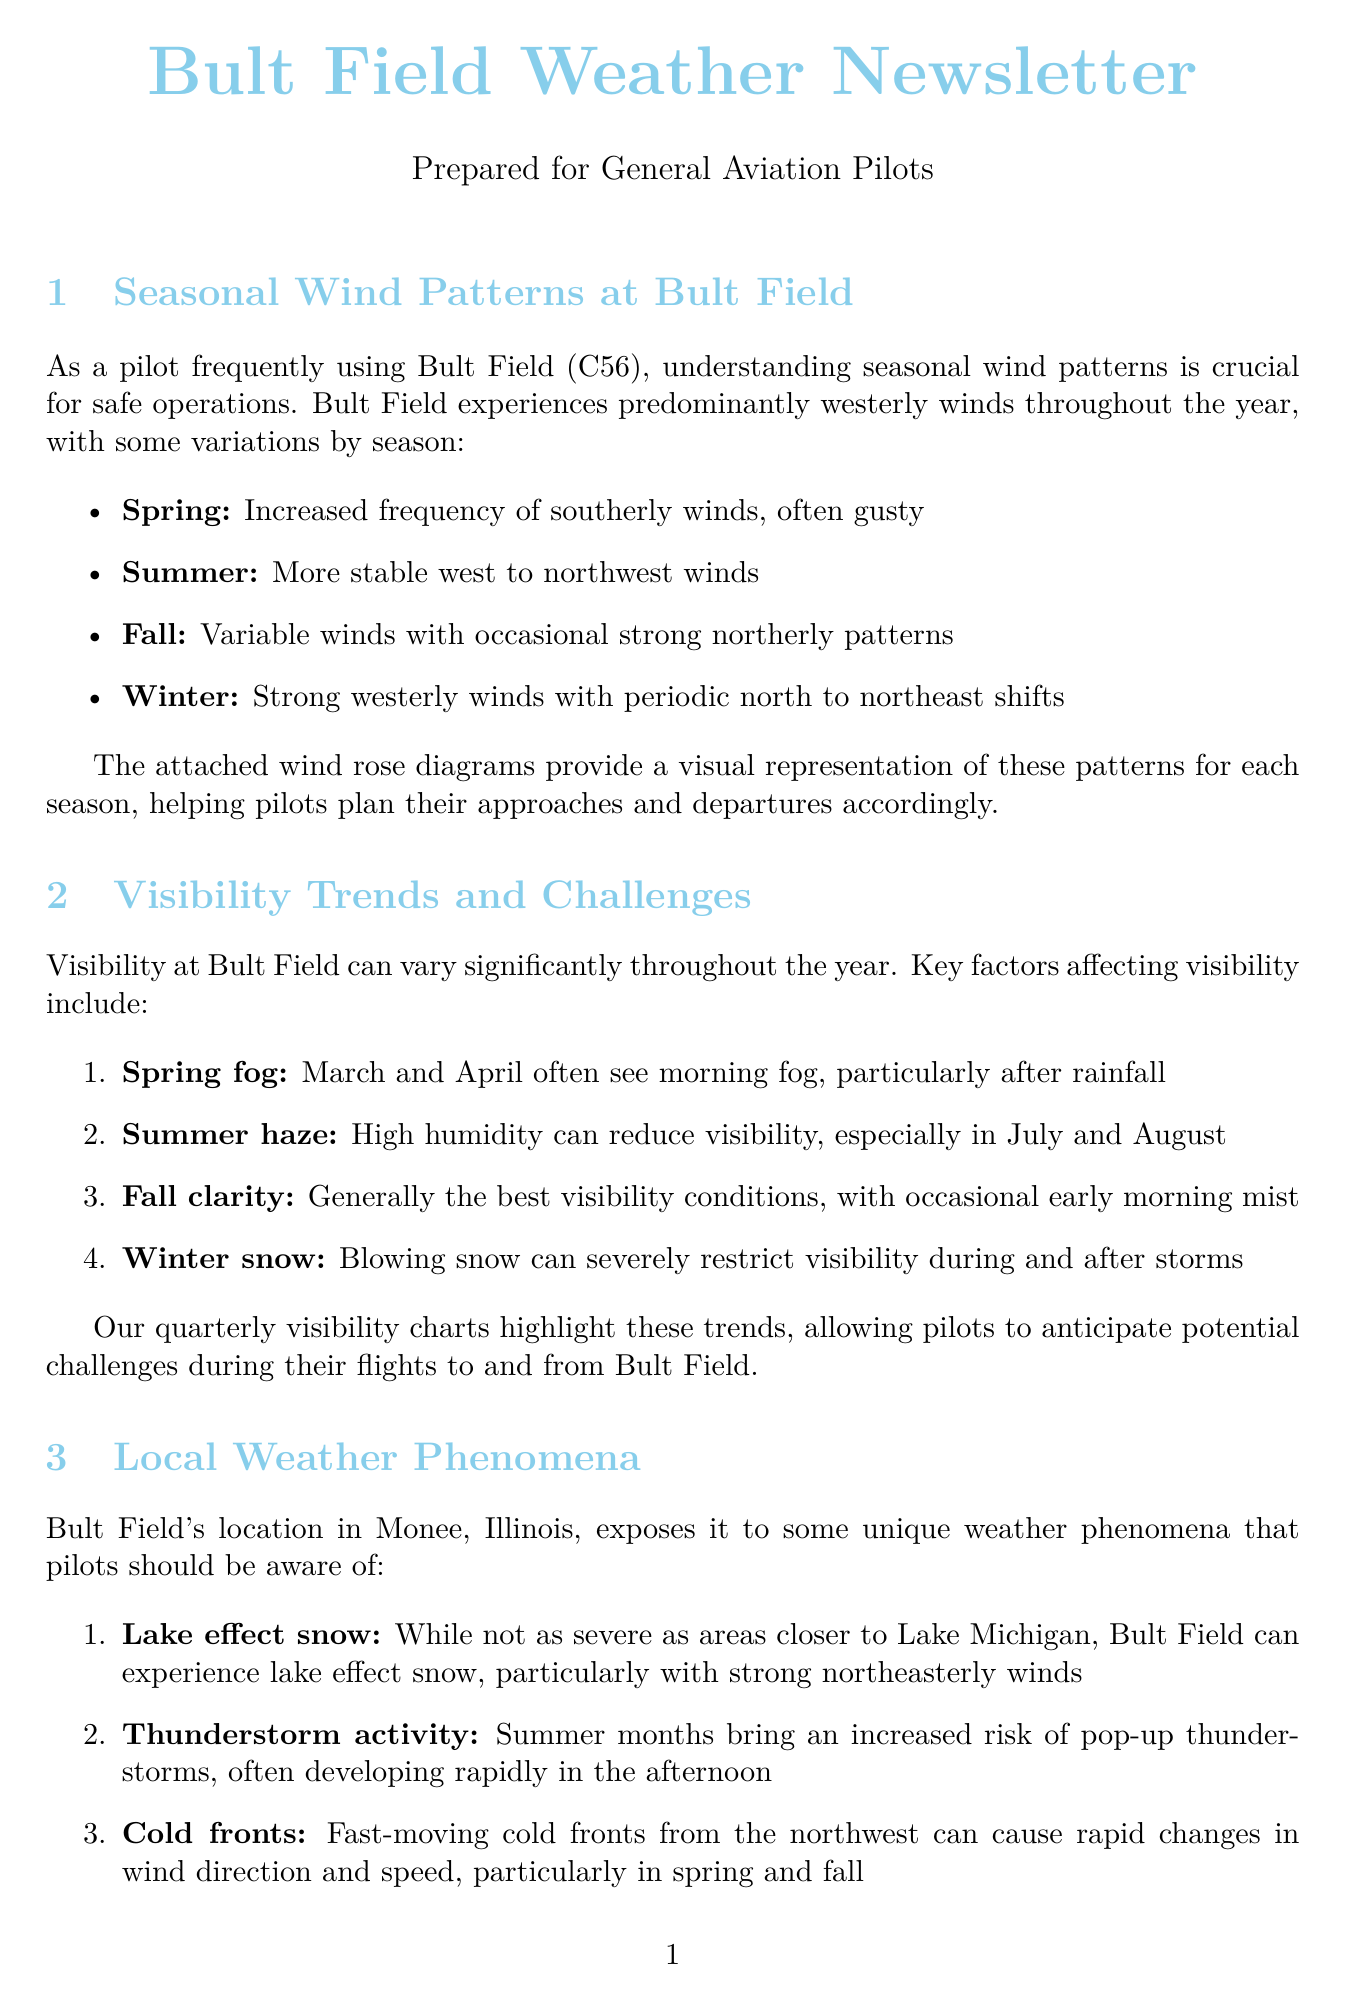What are the predominant winds at Bult Field? The document states that Bult Field experiences predominantly westerly winds throughout the year.
Answer: westerly What is a key factor affecting spring visibility? The document mentions that March and April often see morning fog as a key factor affecting visibility in spring.
Answer: fog Which season sees an increased risk of thunderstorms? According to the document, summer months bring an increased risk of pop-up thunderstorms.
Answer: summer What should pilots be alert for in the fall? The document advises that pilots should be alert for early frost on wings in the fall.
Answer: frost How many resources are listed for weather forecasting? The document lists four resources for pilots to utilize for weather forecasting.
Answer: four What is the expected wind pattern in winter? The document describes that winter features strong westerly winds with periodic north to northeast shifts.
Answer: strong westerly winds What visibility condition is generally best in fall? The document states that fall generally has the best visibility conditions.
Answer: best visibility What specific weather phenomena should pilots be aware of? The document lists lake effect snow, thunderstorms, and cold fronts as unique weather phenomena affecting pilots.
Answer: lake effect snow, thunderstorms, cold fronts 